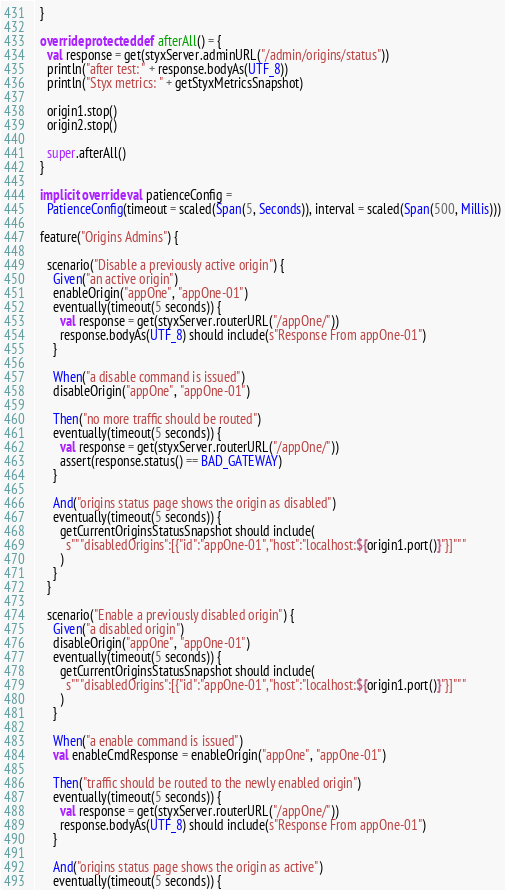<code> <loc_0><loc_0><loc_500><loc_500><_Scala_>  }

  override protected def afterAll() = {
    val response = get(styxServer.adminURL("/admin/origins/status"))
    println("after test: " + response.bodyAs(UTF_8))
    println("Styx metrics: " + getStyxMetricsSnapshot)

    origin1.stop()
    origin2.stop()

    super.afterAll()
  }

  implicit override val patienceConfig =
    PatienceConfig(timeout = scaled(Span(5, Seconds)), interval = scaled(Span(500, Millis)))

  feature("Origins Admins") {

    scenario("Disable a previously active origin") {
      Given("an active origin")
      enableOrigin("appOne", "appOne-01")
      eventually(timeout(5 seconds)) {
        val response = get(styxServer.routerURL("/appOne/"))
        response.bodyAs(UTF_8) should include(s"Response From appOne-01")
      }

      When("a disable command is issued")
      disableOrigin("appOne", "appOne-01")

      Then("no more traffic should be routed")
      eventually(timeout(5 seconds)) {
        val response = get(styxServer.routerURL("/appOne/"))
        assert(response.status() == BAD_GATEWAY)
      }

      And("origins status page shows the origin as disabled")
      eventually(timeout(5 seconds)) {
        getCurrentOriginsStatusSnapshot should include(
          s"""disabledOrigins":[{"id":"appOne-01","host":"localhost:${origin1.port()}"}]"""
        )
      }
    }

    scenario("Enable a previously disabled origin") {
      Given("a disabled origin")
      disableOrigin("appOne", "appOne-01")
      eventually(timeout(5 seconds)) {
        getCurrentOriginsStatusSnapshot should include(
          s"""disabledOrigins":[{"id":"appOne-01","host":"localhost:${origin1.port()}"}]"""
        )
      }

      When("a enable command is issued")
      val enableCmdResponse = enableOrigin("appOne", "appOne-01")

      Then("traffic should be routed to the newly enabled origin")
      eventually(timeout(5 seconds)) {
        val response = get(styxServer.routerURL("/appOne/"))
        response.bodyAs(UTF_8) should include(s"Response From appOne-01")
      }

      And("origins status page shows the origin as active")
      eventually(timeout(5 seconds)) {</code> 